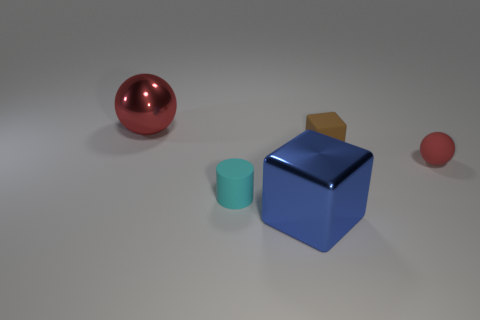Subtract all purple cylinders. Subtract all gray spheres. How many cylinders are left? 1 Add 4 green matte objects. How many objects exist? 9 Subtract all spheres. How many objects are left? 3 Subtract all tiny red matte balls. Subtract all small brown matte cylinders. How many objects are left? 4 Add 3 tiny red matte things. How many tiny red matte things are left? 4 Add 2 small red shiny spheres. How many small red shiny spheres exist? 2 Subtract 0 green cylinders. How many objects are left? 5 